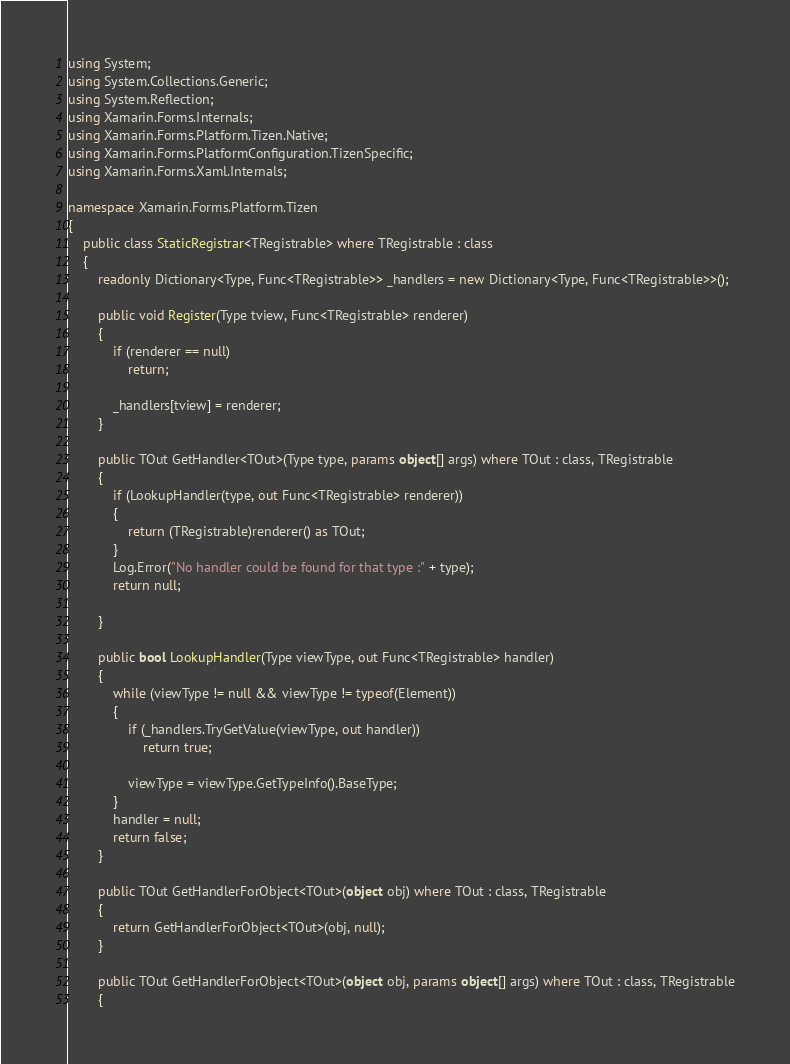<code> <loc_0><loc_0><loc_500><loc_500><_C#_>using System;
using System.Collections.Generic;
using System.Reflection;
using Xamarin.Forms.Internals;
using Xamarin.Forms.Platform.Tizen.Native;
using Xamarin.Forms.PlatformConfiguration.TizenSpecific;
using Xamarin.Forms.Xaml.Internals;

namespace Xamarin.Forms.Platform.Tizen
{
	public class StaticRegistrar<TRegistrable> where TRegistrable : class
	{
		readonly Dictionary<Type, Func<TRegistrable>> _handlers = new Dictionary<Type, Func<TRegistrable>>();

		public void Register(Type tview, Func<TRegistrable> renderer)
		{
			if (renderer == null)
				return;

			_handlers[tview] = renderer;
		}

		public TOut GetHandler<TOut>(Type type, params object[] args) where TOut : class, TRegistrable
		{
			if (LookupHandler(type, out Func<TRegistrable> renderer))
			{
				return (TRegistrable)renderer() as TOut;
			}
			Log.Error("No handler could be found for that type :" + type);
			return null;

		}

		public bool LookupHandler(Type viewType, out Func<TRegistrable> handler)
		{
			while (viewType != null && viewType != typeof(Element))
			{
				if (_handlers.TryGetValue(viewType, out handler))
					return true;

				viewType = viewType.GetTypeInfo().BaseType;
			}
			handler = null;
			return false;
		}

		public TOut GetHandlerForObject<TOut>(object obj) where TOut : class, TRegistrable
		{
			return GetHandlerForObject<TOut>(obj, null);
		}

		public TOut GetHandlerForObject<TOut>(object obj, params object[] args) where TOut : class, TRegistrable
		{</code> 